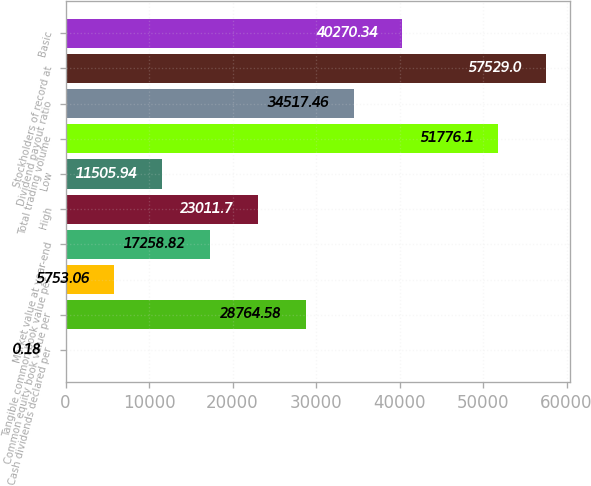<chart> <loc_0><loc_0><loc_500><loc_500><bar_chart><fcel>Cash dividends declared per<fcel>Common equity book value per<fcel>Tangible common book value per<fcel>Market value at year-end<fcel>High<fcel>Low<fcel>Total trading volume<fcel>Dividend payout ratio<fcel>Stockholders of record at<fcel>Basic<nl><fcel>0.18<fcel>28764.6<fcel>5753.06<fcel>17258.8<fcel>23011.7<fcel>11505.9<fcel>51776.1<fcel>34517.5<fcel>57529<fcel>40270.3<nl></chart> 